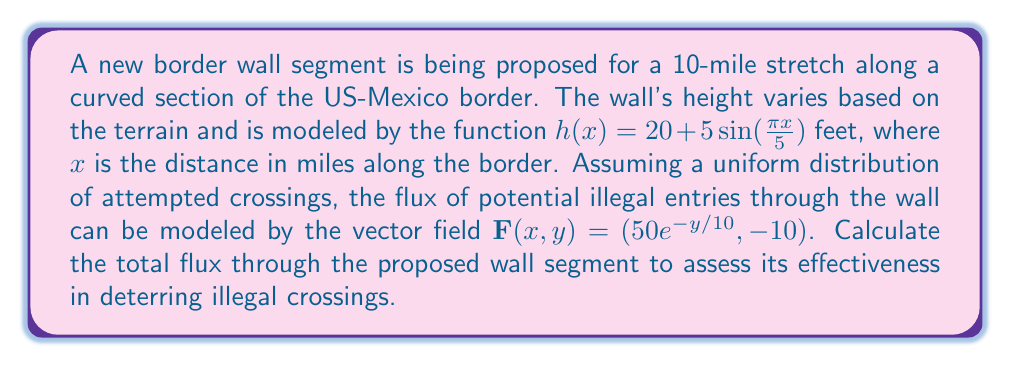Solve this math problem. To solve this problem, we need to use a surface integral of the flux. The steps are as follows:

1) The surface of the wall can be parameterized as:
   $r(x,y) = (x, 0, y)$ where $0 \leq x \leq 10$ and $0 \leq y \leq h(x)$

2) The normal vector to the surface is:
   $\mathbf{n} = (0, -1, 0)$

3) The flux through the surface is given by the surface integral:
   $$\iint_S \mathbf{F} \cdot \mathbf{n} \, dS$$

4) Substituting our vector field and normal vector:
   $$\iint_S (50e^{-y/10}, -10) \cdot (0, -1, 0) \, dS = \iint_S 10 \, dS$$

5) We can convert this to a double integral:
   $$\int_0^{10} \int_0^{h(x)} 10 \, dy \, dx$$

6) Evaluating the inner integral:
   $$\int_0^{10} 10h(x) \, dx = \int_0^{10} 10(20 + 5\sin(\frac{\pi x}{5})) \, dx$$

7) Simplifying:
   $$200\int_0^{10} dx + 50\int_0^{10} \sin(\frac{\pi x}{5}) \, dx$$

8) Evaluating:
   $$200x \bigg|_0^{10} - \frac{250}{\pi/5}\cos(\frac{\pi x}{5}) \bigg|_0^{10}$$
   
   $$= 2000 - \frac{250}{\pi/5}(\cos(2\pi) - \cos(0))$$
   
   $$= 2000 - \frac{250}{\pi/5}(1 - 1) = 2000$$

Therefore, the total flux through the wall segment is 2000 units.
Answer: The total flux through the proposed wall segment is 2000 units. 